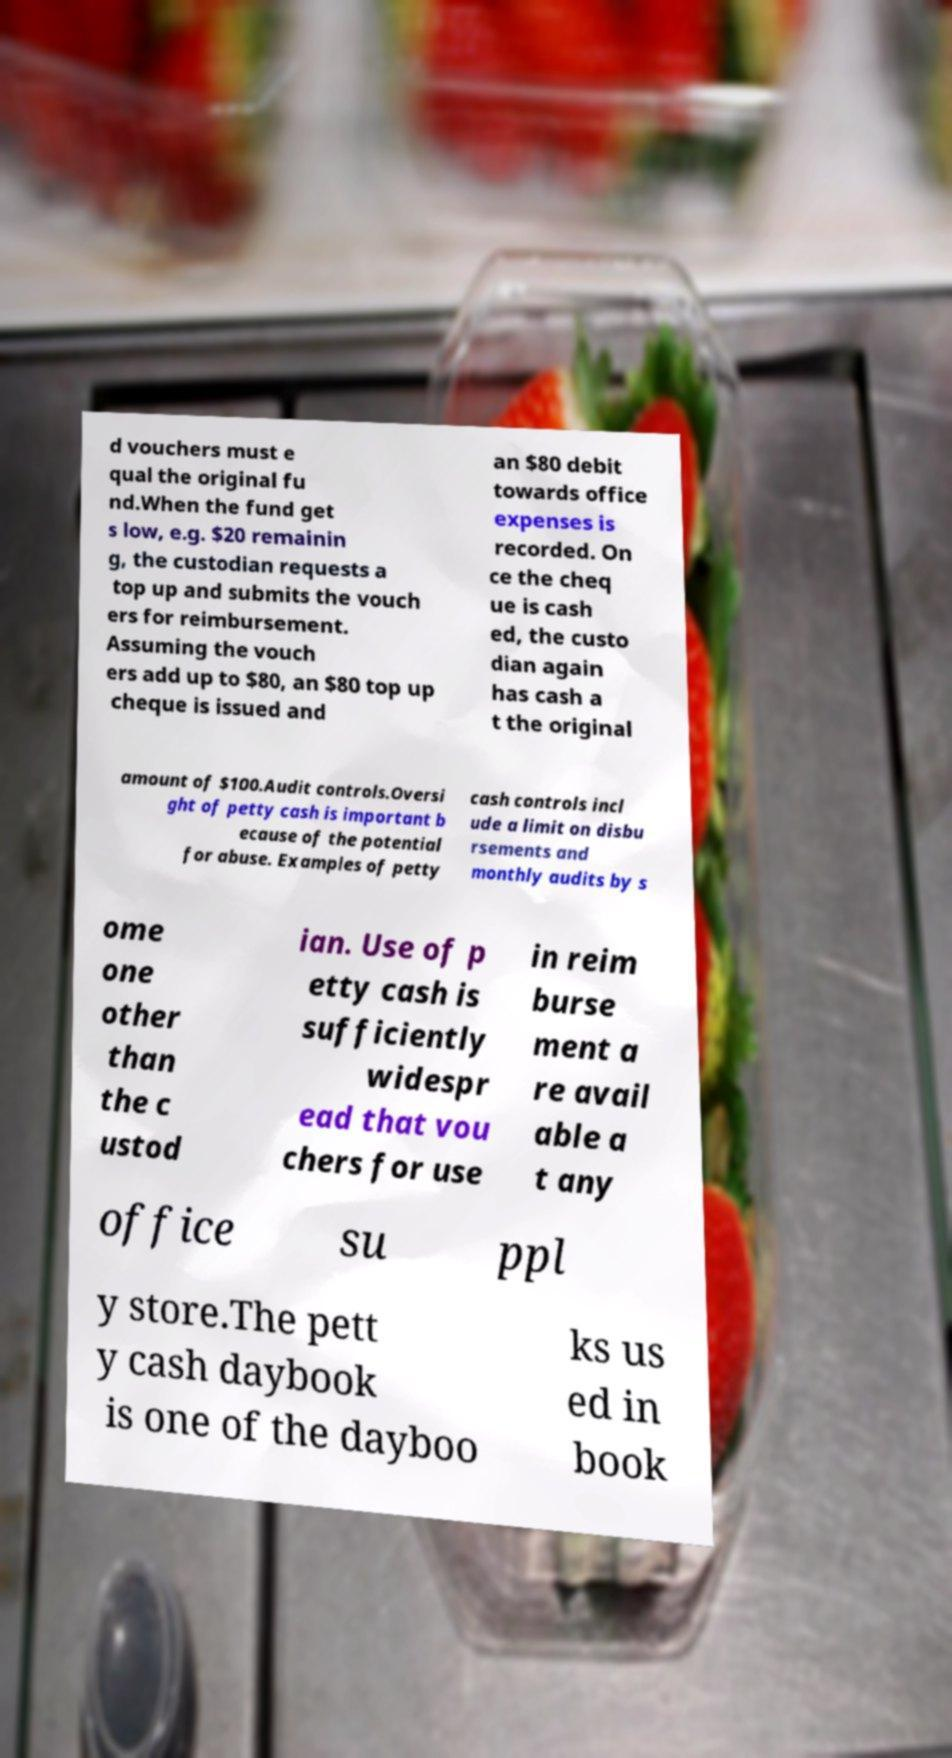Can you accurately transcribe the text from the provided image for me? d vouchers must e qual the original fu nd.When the fund get s low, e.g. $20 remainin g, the custodian requests a top up and submits the vouch ers for reimbursement. Assuming the vouch ers add up to $80, an $80 top up cheque is issued and an $80 debit towards office expenses is recorded. On ce the cheq ue is cash ed, the custo dian again has cash a t the original amount of $100.Audit controls.Oversi ght of petty cash is important b ecause of the potential for abuse. Examples of petty cash controls incl ude a limit on disbu rsements and monthly audits by s ome one other than the c ustod ian. Use of p etty cash is sufficiently widespr ead that vou chers for use in reim burse ment a re avail able a t any office su ppl y store.The pett y cash daybook is one of the dayboo ks us ed in book 